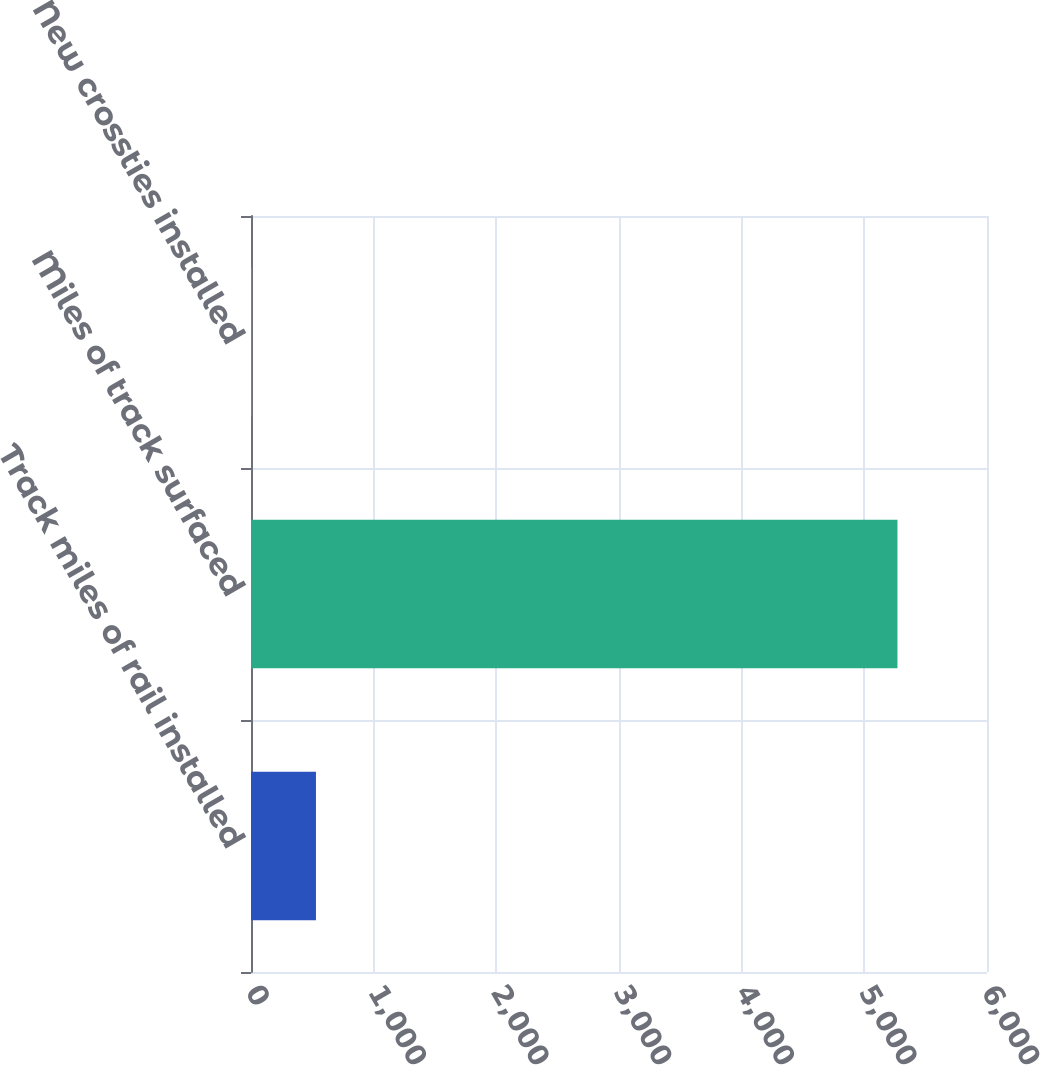Convert chart. <chart><loc_0><loc_0><loc_500><loc_500><bar_chart><fcel>Track miles of rail installed<fcel>Miles of track surfaced<fcel>New crossties installed<nl><fcel>529.52<fcel>5270<fcel>2.8<nl></chart> 